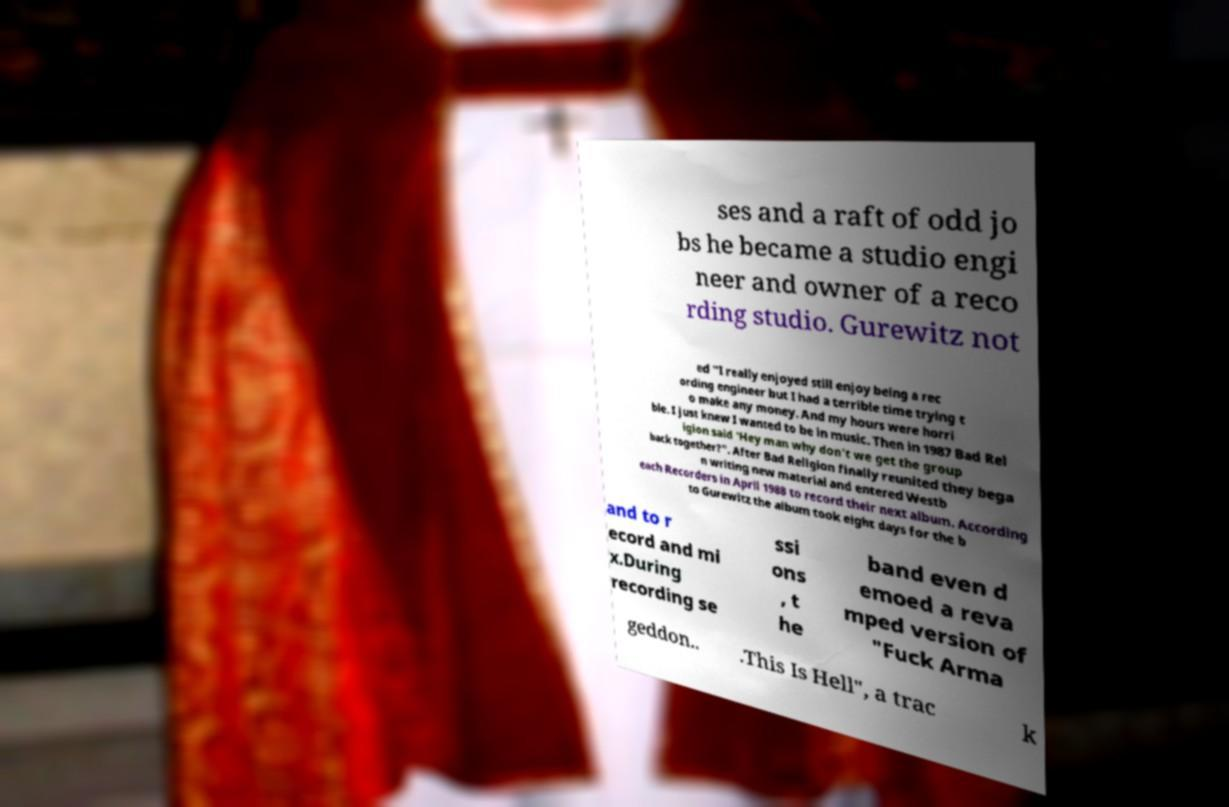What messages or text are displayed in this image? I need them in a readable, typed format. ses and a raft of odd jo bs he became a studio engi neer and owner of a reco rding studio. Gurewitz not ed "I really enjoyed still enjoy being a rec ording engineer but I had a terrible time trying t o make any money. And my hours were horri ble. I just knew I wanted to be in music. Then in 1987 Bad Rel igion said 'Hey man why don't we get the group back together?". After Bad Religion finally reunited they bega n writing new material and entered Westb each Recorders in April 1988 to record their next album. According to Gurewitz the album took eight days for the b and to r ecord and mi x.During recording se ssi ons , t he band even d emoed a reva mped version of "Fuck Arma geddon.. .This Is Hell", a trac k 